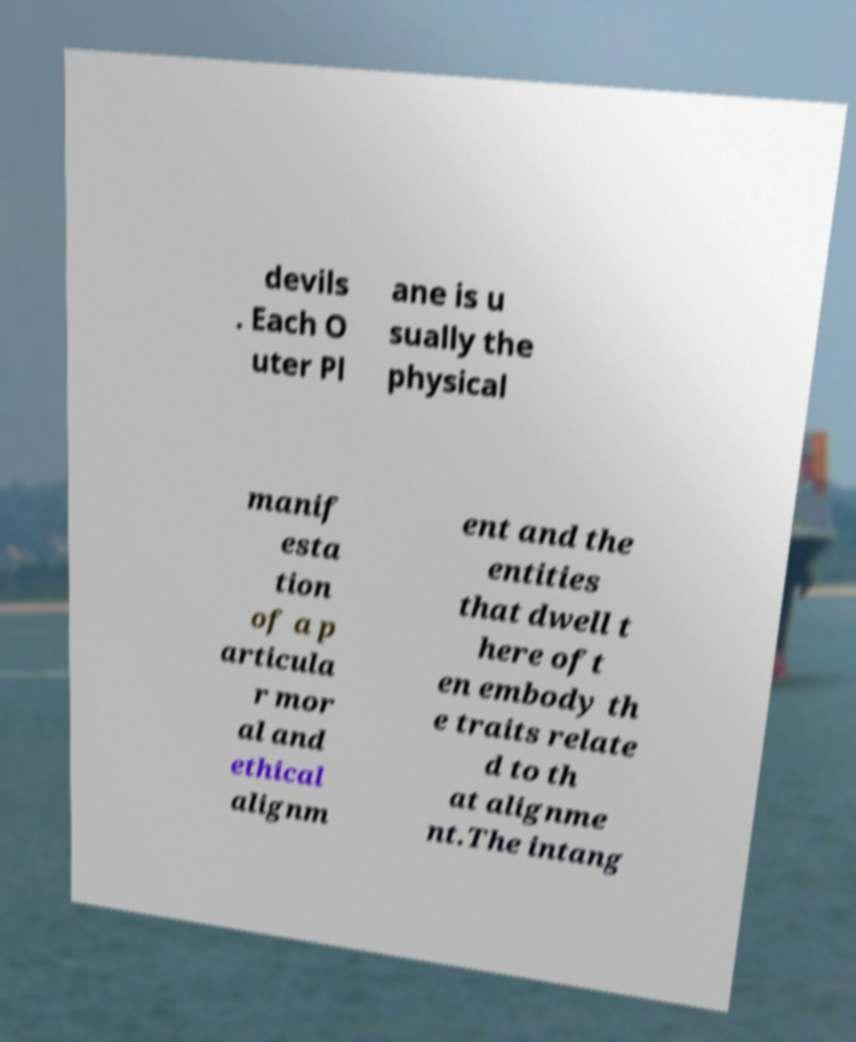There's text embedded in this image that I need extracted. Can you transcribe it verbatim? devils . Each O uter Pl ane is u sually the physical manif esta tion of a p articula r mor al and ethical alignm ent and the entities that dwell t here oft en embody th e traits relate d to th at alignme nt.The intang 